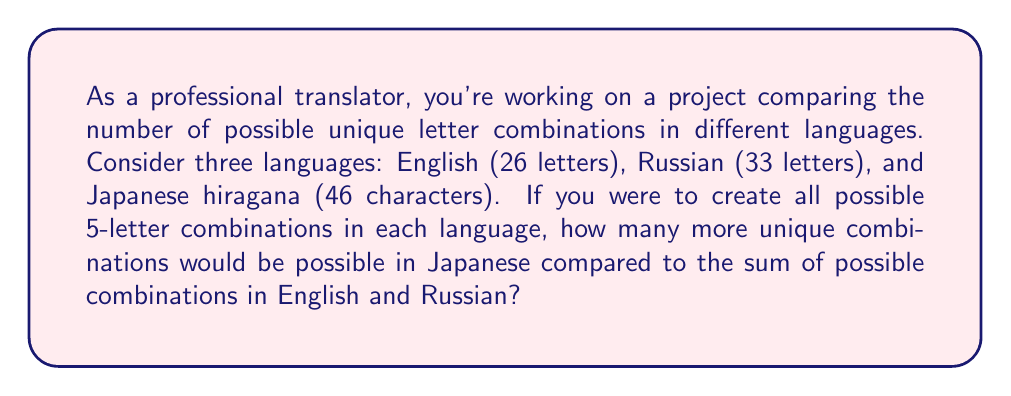Can you answer this question? To solve this problem, we'll use the concept of permutations with repetition from combinatorics. The formula for the number of permutations with repetition is:

$$n^r$$

Where $n$ is the number of available characters, and $r$ is the length of the combination.

For each language:

1. English (26 letters):
   $$26^5 = 11,881,376$$

2. Russian (33 letters):
   $$33^5 = 39,135,393$$

3. Japanese hiragana (46 characters):
   $$46^5 = 205,962,976$$

Now, let's calculate the difference:

1. Sum of English and Russian combinations:
   $$11,881,376 + 39,135,393 = 51,016,769$$

2. Difference between Japanese and the sum of English and Russian:
   $$205,962,976 - 51,016,769 = 154,946,207$$

Therefore, Japanese hiragana would have 154,946,207 more unique 5-letter combinations than the sum of English and Russian combinations.
Answer: 154,946,207 